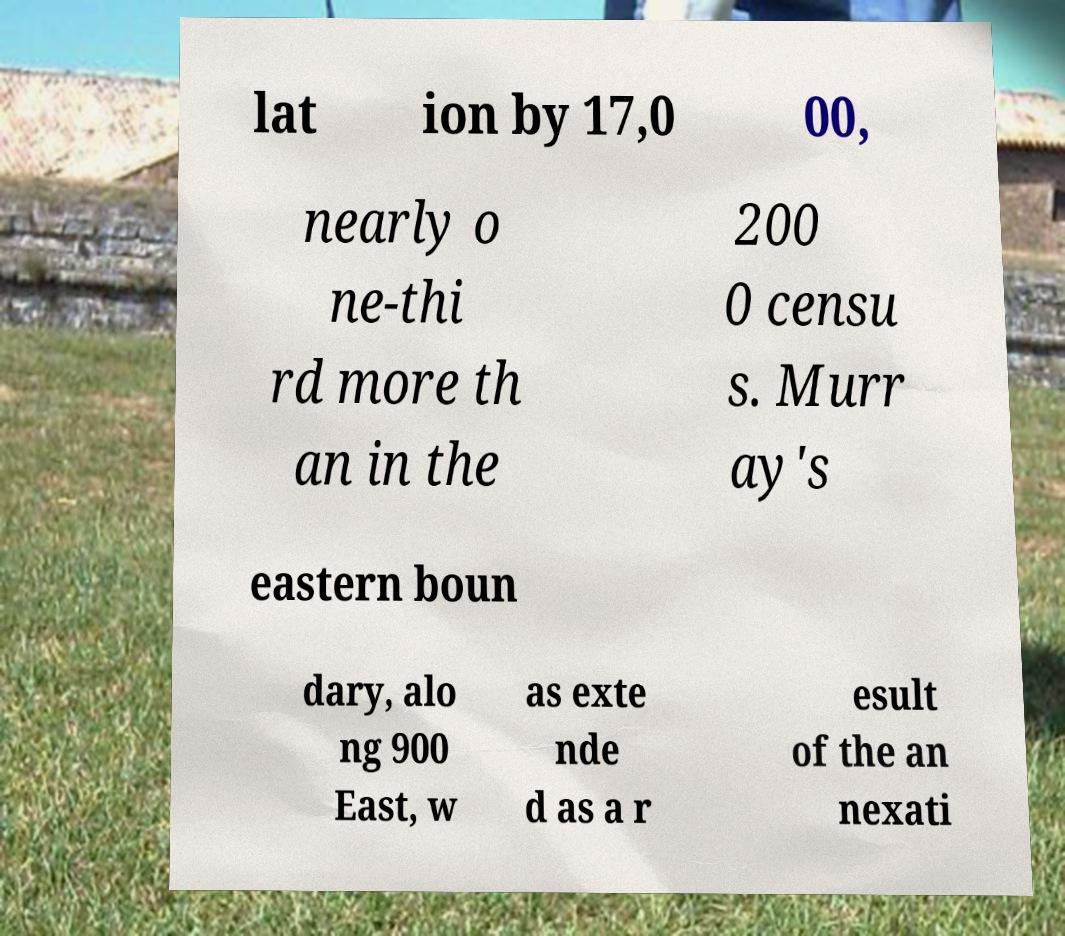There's text embedded in this image that I need extracted. Can you transcribe it verbatim? lat ion by 17,0 00, nearly o ne-thi rd more th an in the 200 0 censu s. Murr ay's eastern boun dary, alo ng 900 East, w as exte nde d as a r esult of the an nexati 